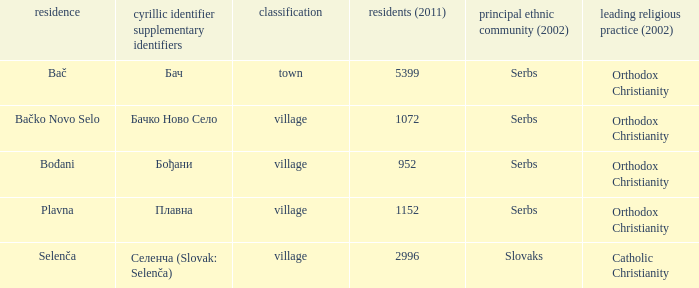How to you write  плавна with the latin alphabet? Plavna. 